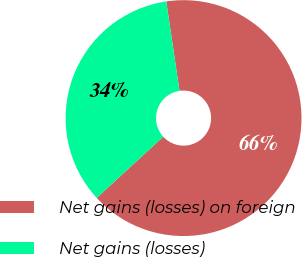Convert chart. <chart><loc_0><loc_0><loc_500><loc_500><pie_chart><fcel>Net gains (losses) on foreign<fcel>Net gains (losses)<nl><fcel>65.52%<fcel>34.48%<nl></chart> 